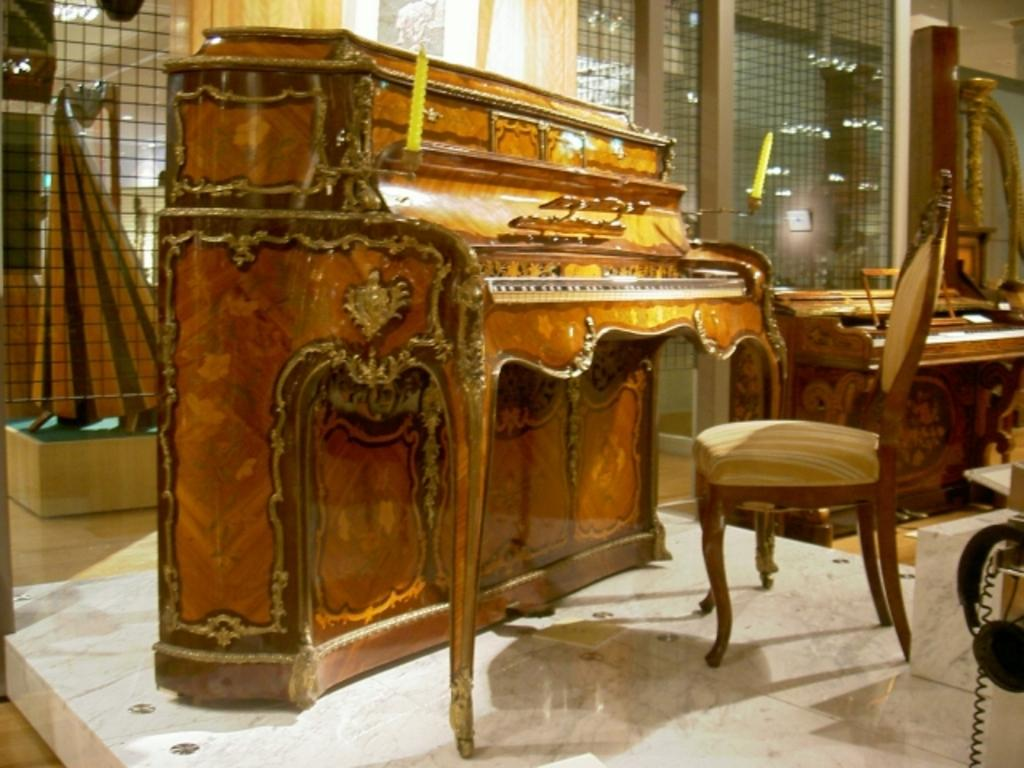What type of material is the piano made of in the image? The piano is made of wood in the image. What is positioned in front of the piano? There is a chair in front of the piano. What can be seen in the background of the image? There is a fence and another piano visible in the background. What type of theory is being discussed by the ghost sitting on the piano in the image? There is no ghost present in the image, and therefore no theory is being discussed. 